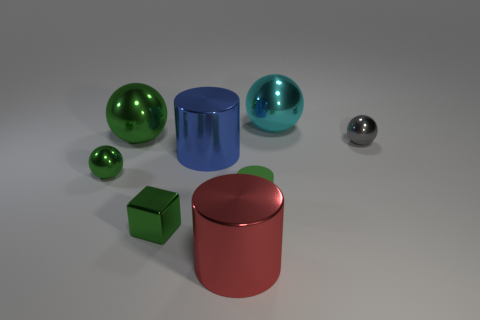Add 2 red shiny cylinders. How many objects exist? 10 Subtract all cylinders. How many objects are left? 5 Subtract all large blue cylinders. Subtract all small cylinders. How many objects are left? 6 Add 8 big blue metallic things. How many big blue metallic things are left? 9 Add 4 tiny blue cylinders. How many tiny blue cylinders exist? 4 Subtract 1 green cubes. How many objects are left? 7 